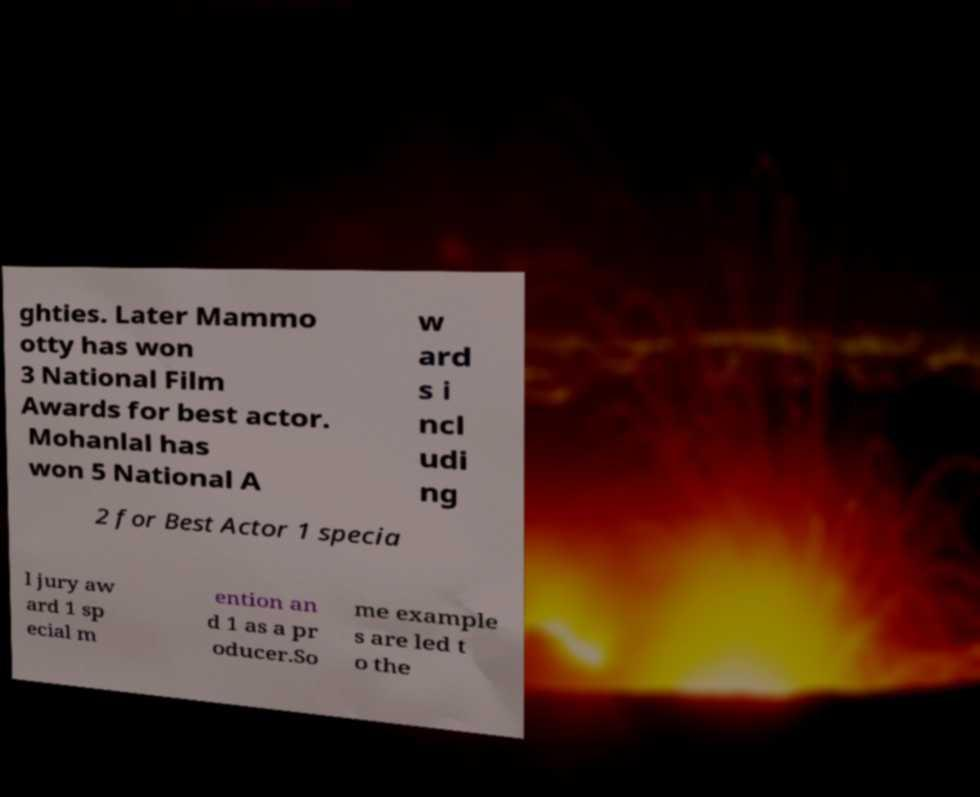Could you assist in decoding the text presented in this image and type it out clearly? ghties. Later Mammo otty has won 3 National Film Awards for best actor. Mohanlal has won 5 National A w ard s i ncl udi ng 2 for Best Actor 1 specia l jury aw ard 1 sp ecial m ention an d 1 as a pr oducer.So me example s are led t o the 